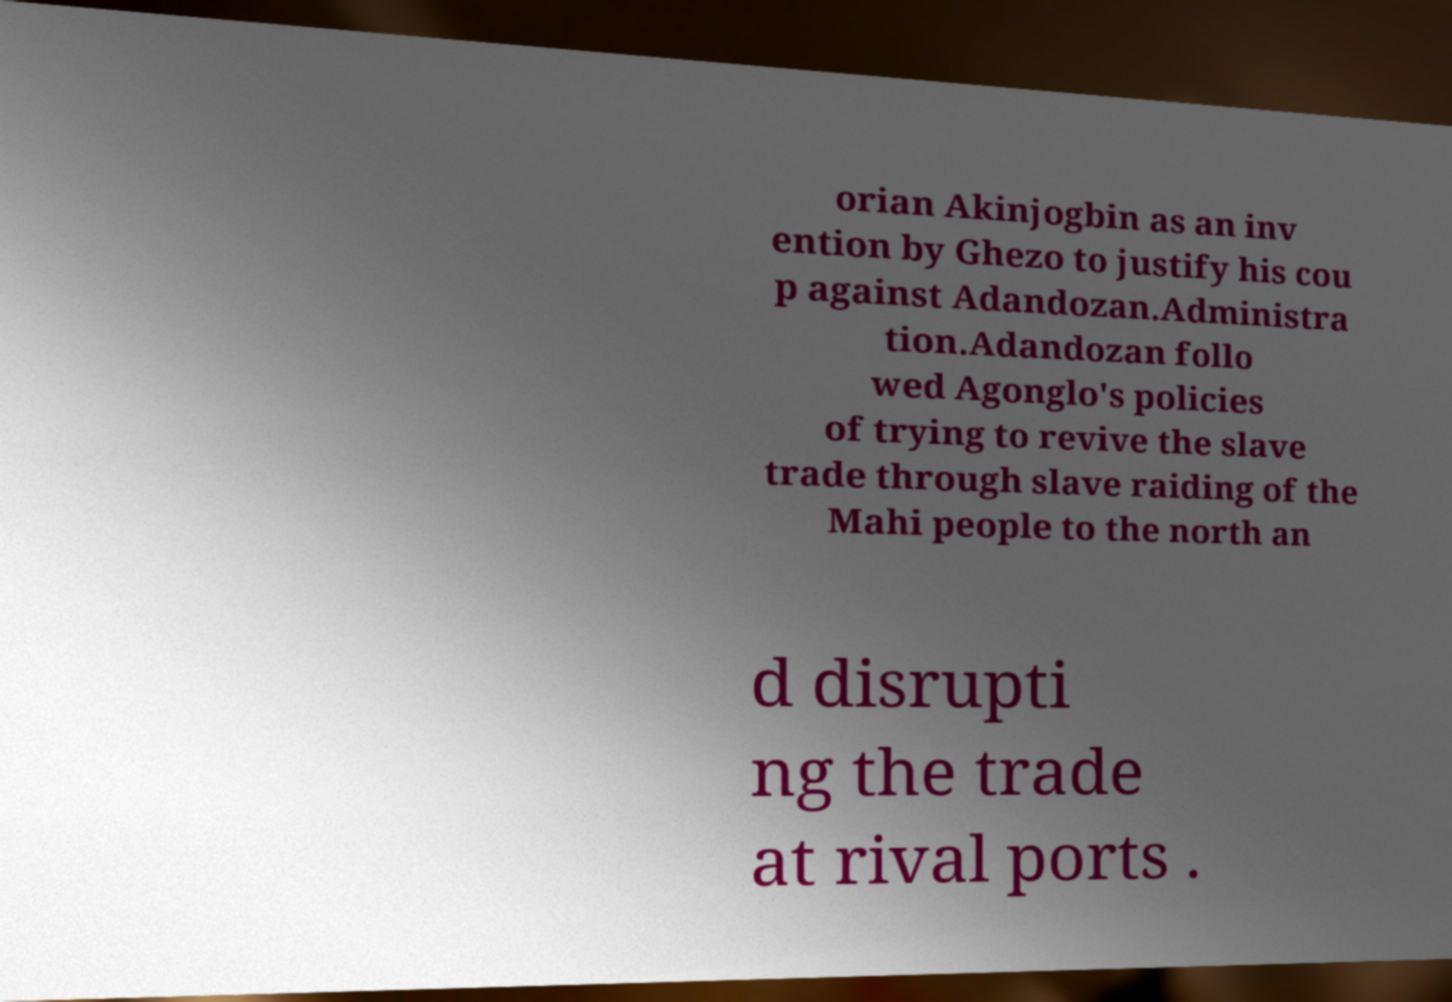Can you read and provide the text displayed in the image?This photo seems to have some interesting text. Can you extract and type it out for me? orian Akinjogbin as an inv ention by Ghezo to justify his cou p against Adandozan.Administra tion.Adandozan follo wed Agonglo's policies of trying to revive the slave trade through slave raiding of the Mahi people to the north an d disrupti ng the trade at rival ports . 